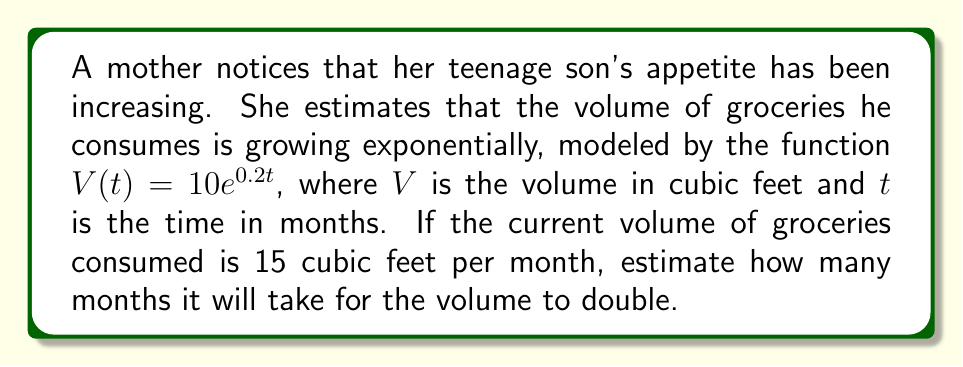Can you solve this math problem? Let's approach this step-by-step:

1) We're given that $V(t) = 10e^{0.2t}$ and that the current volume is 15 cubic feet.

2) We need to find $t$ when $V(t) = 30$ (double the current volume).

3) Let's set up the equation:
   $30 = 10e^{0.2t}$

4) Divide both sides by 10:
   $3 = e^{0.2t}$

5) Take the natural log of both sides:
   $\ln(3) = \ln(e^{0.2t})$

6) Simplify the right side using the properties of logarithms:
   $\ln(3) = 0.2t$

7) Solve for $t$:
   $t = \frac{\ln(3)}{0.2}$

8) Calculate the value:
   $t = \frac{\ln(3)}{0.2} \approx 5.4935$

9) Since we're dealing with months, we should round to the nearest whole number.
Answer: It will take approximately 5 months for the volume of groceries consumed to double. 